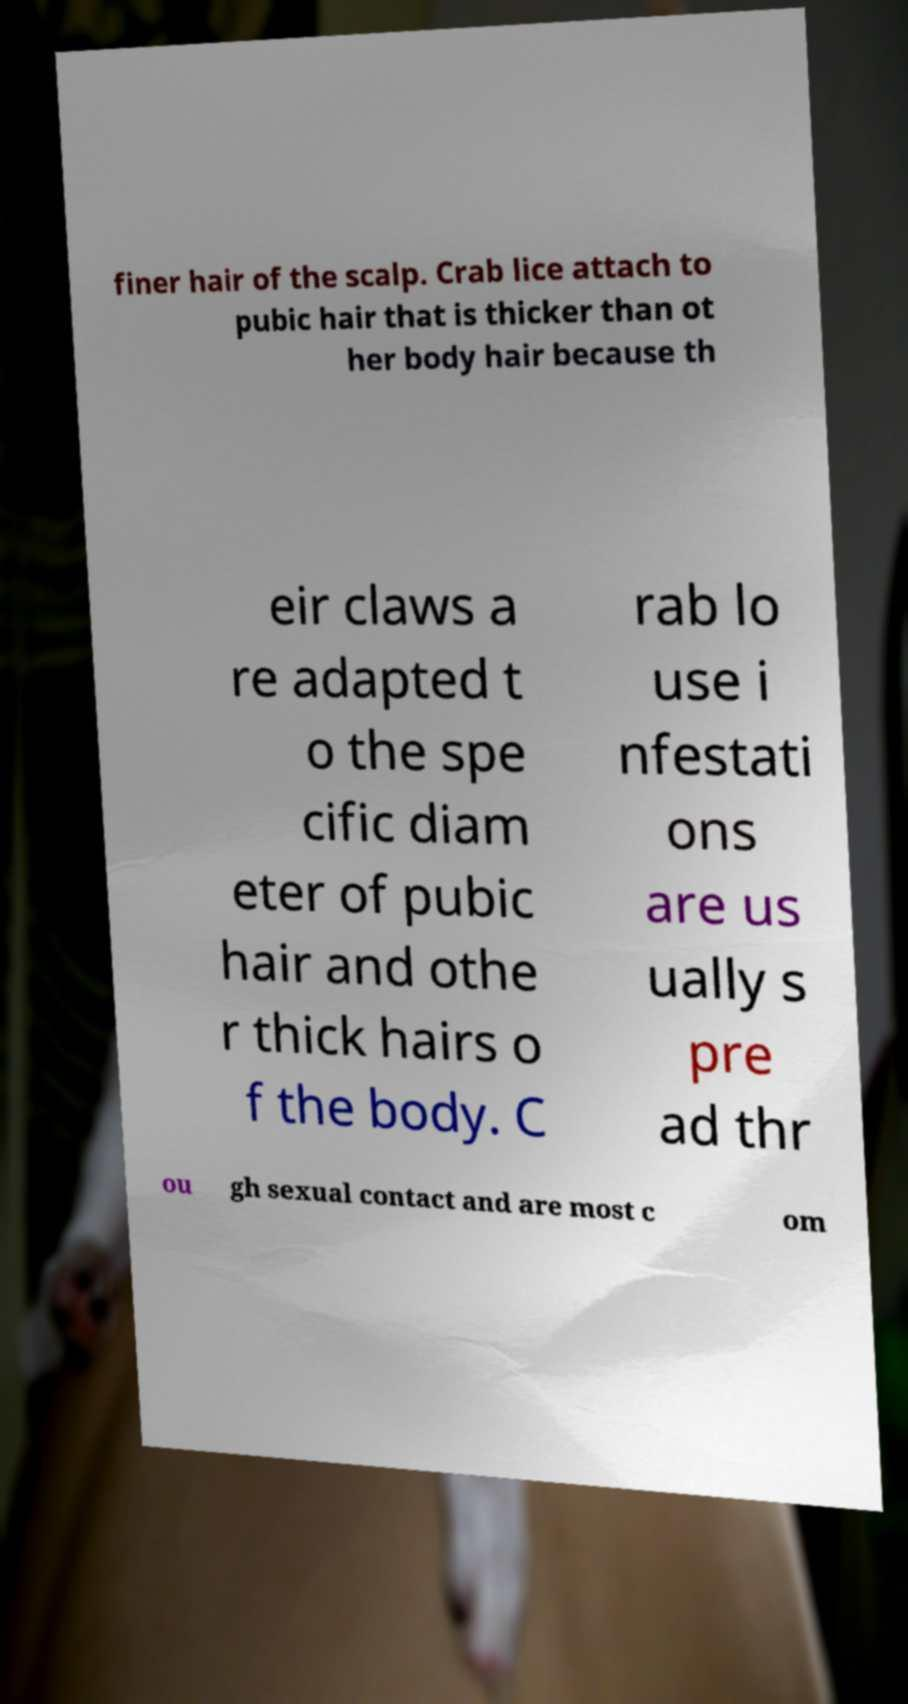There's text embedded in this image that I need extracted. Can you transcribe it verbatim? finer hair of the scalp. Crab lice attach to pubic hair that is thicker than ot her body hair because th eir claws a re adapted t o the spe cific diam eter of pubic hair and othe r thick hairs o f the body. C rab lo use i nfestati ons are us ually s pre ad thr ou gh sexual contact and are most c om 